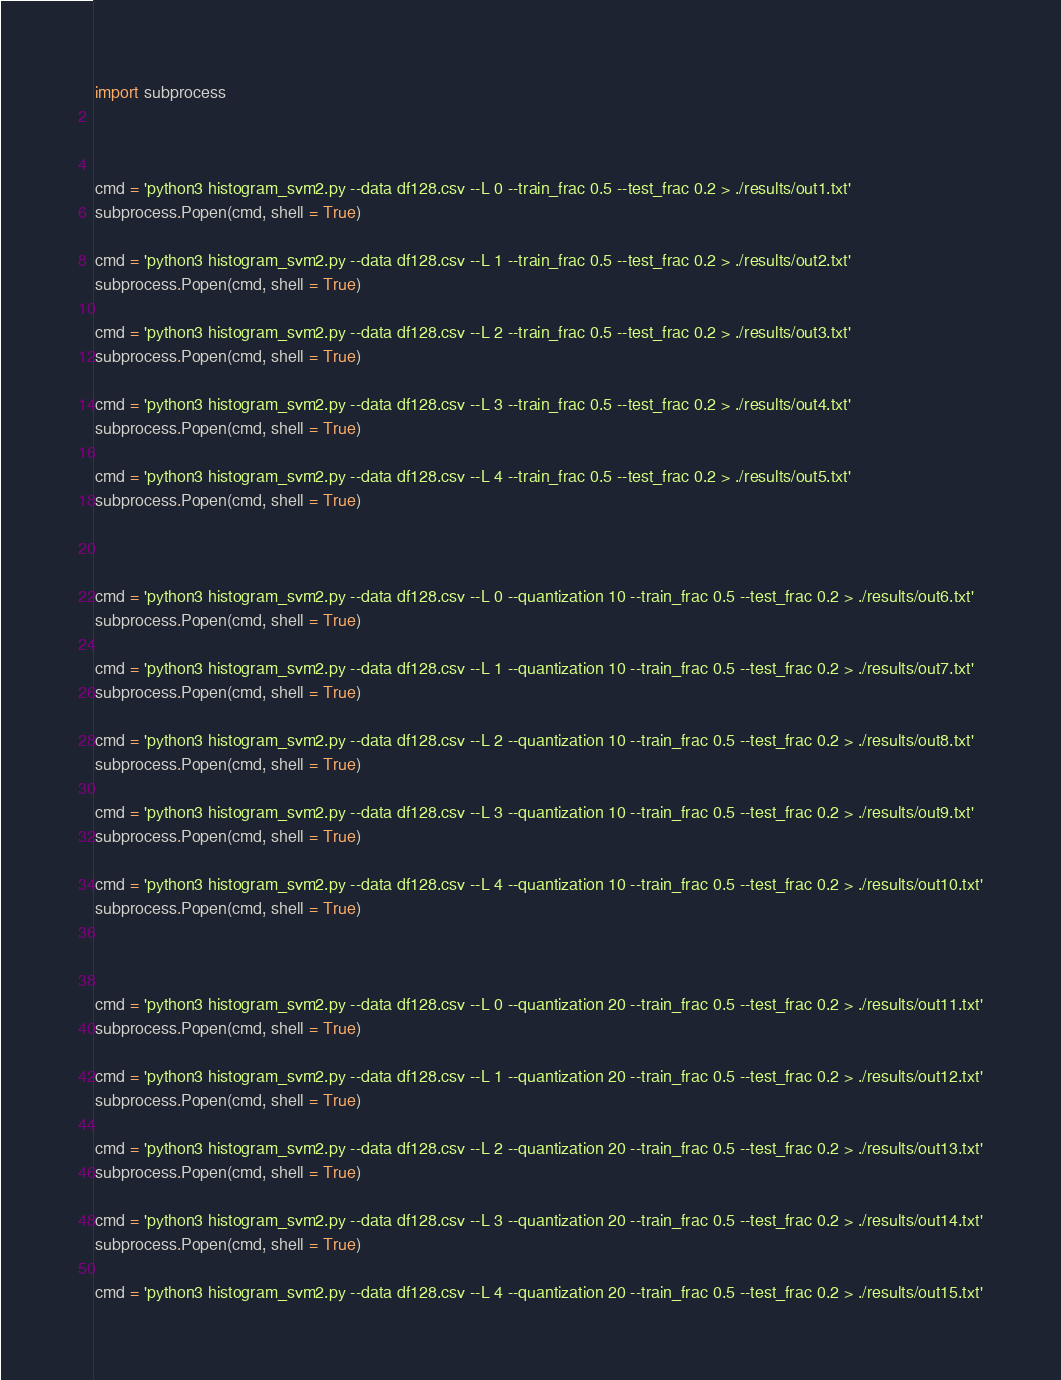<code> <loc_0><loc_0><loc_500><loc_500><_Python_>import subprocess



cmd = 'python3 histogram_svm2.py --data df128.csv --L 0 --train_frac 0.5 --test_frac 0.2 > ./results/out1.txt'
subprocess.Popen(cmd, shell = True)

cmd = 'python3 histogram_svm2.py --data df128.csv --L 1 --train_frac 0.5 --test_frac 0.2 > ./results/out2.txt'
subprocess.Popen(cmd, shell = True)

cmd = 'python3 histogram_svm2.py --data df128.csv --L 2 --train_frac 0.5 --test_frac 0.2 > ./results/out3.txt'
subprocess.Popen(cmd, shell = True)

cmd = 'python3 histogram_svm2.py --data df128.csv --L 3 --train_frac 0.5 --test_frac 0.2 > ./results/out4.txt'
subprocess.Popen(cmd, shell = True)

cmd = 'python3 histogram_svm2.py --data df128.csv --L 4 --train_frac 0.5 --test_frac 0.2 > ./results/out5.txt'
subprocess.Popen(cmd, shell = True)



cmd = 'python3 histogram_svm2.py --data df128.csv --L 0 --quantization 10 --train_frac 0.5 --test_frac 0.2 > ./results/out6.txt'
subprocess.Popen(cmd, shell = True)

cmd = 'python3 histogram_svm2.py --data df128.csv --L 1 --quantization 10 --train_frac 0.5 --test_frac 0.2 > ./results/out7.txt'
subprocess.Popen(cmd, shell = True)

cmd = 'python3 histogram_svm2.py --data df128.csv --L 2 --quantization 10 --train_frac 0.5 --test_frac 0.2 > ./results/out8.txt'
subprocess.Popen(cmd, shell = True)

cmd = 'python3 histogram_svm2.py --data df128.csv --L 3 --quantization 10 --train_frac 0.5 --test_frac 0.2 > ./results/out9.txt'
subprocess.Popen(cmd, shell = True)

cmd = 'python3 histogram_svm2.py --data df128.csv --L 4 --quantization 10 --train_frac 0.5 --test_frac 0.2 > ./results/out10.txt'
subprocess.Popen(cmd, shell = True)



cmd = 'python3 histogram_svm2.py --data df128.csv --L 0 --quantization 20 --train_frac 0.5 --test_frac 0.2 > ./results/out11.txt'
subprocess.Popen(cmd, shell = True)

cmd = 'python3 histogram_svm2.py --data df128.csv --L 1 --quantization 20 --train_frac 0.5 --test_frac 0.2 > ./results/out12.txt'
subprocess.Popen(cmd, shell = True)

cmd = 'python3 histogram_svm2.py --data df128.csv --L 2 --quantization 20 --train_frac 0.5 --test_frac 0.2 > ./results/out13.txt'
subprocess.Popen(cmd, shell = True)

cmd = 'python3 histogram_svm2.py --data df128.csv --L 3 --quantization 20 --train_frac 0.5 --test_frac 0.2 > ./results/out14.txt'
subprocess.Popen(cmd, shell = True)

cmd = 'python3 histogram_svm2.py --data df128.csv --L 4 --quantization 20 --train_frac 0.5 --test_frac 0.2 > ./results/out15.txt'</code> 